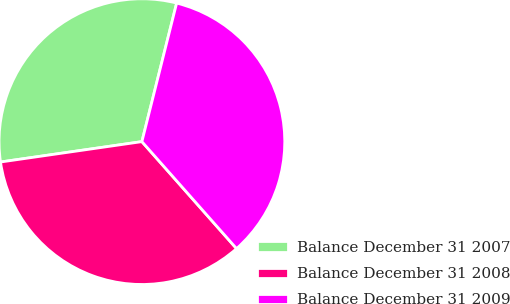Convert chart. <chart><loc_0><loc_0><loc_500><loc_500><pie_chart><fcel>Balance December 31 2007<fcel>Balance December 31 2008<fcel>Balance December 31 2009<nl><fcel>31.19%<fcel>34.25%<fcel>34.56%<nl></chart> 